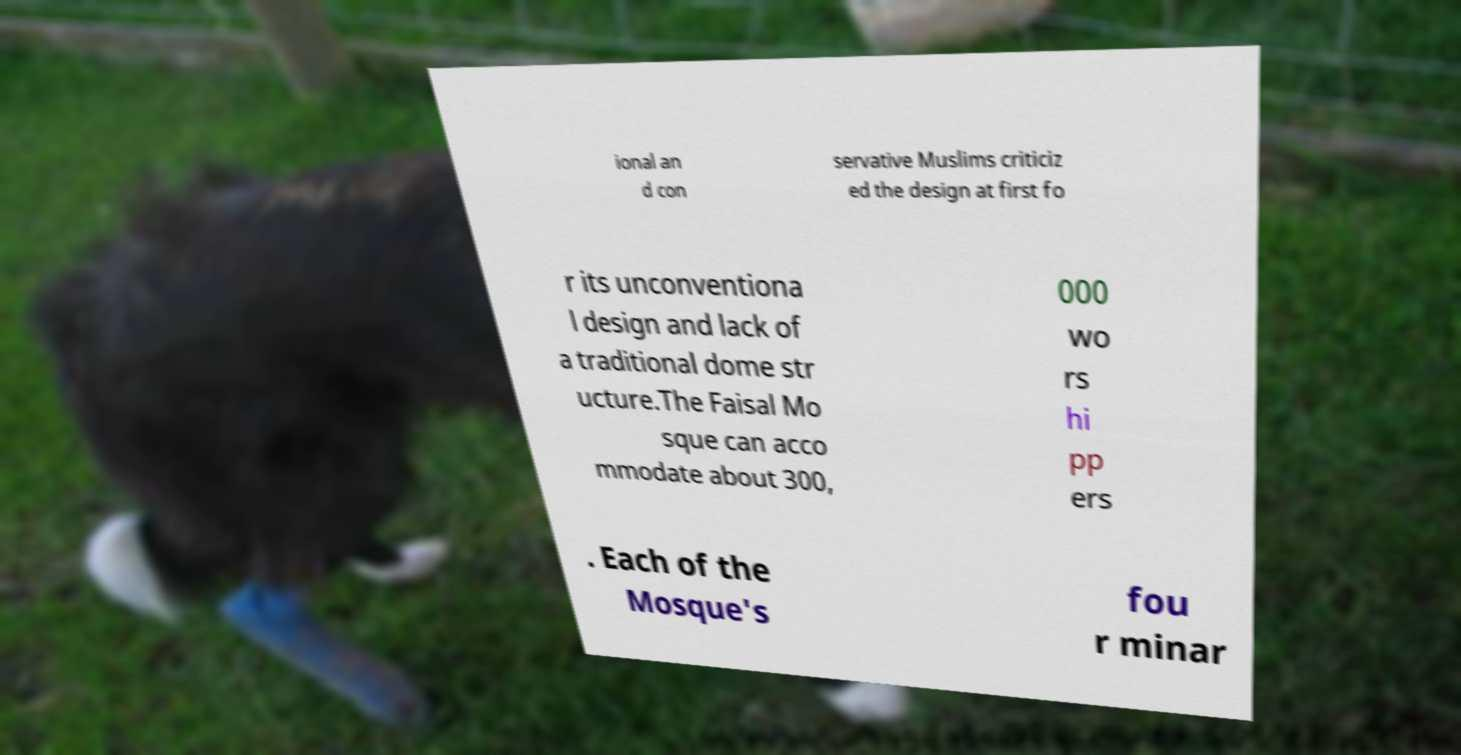Could you extract and type out the text from this image? ional an d con servative Muslims criticiz ed the design at first fo r its unconventiona l design and lack of a traditional dome str ucture.The Faisal Mo sque can acco mmodate about 300, 000 wo rs hi pp ers . Each of the Mosque's fou r minar 